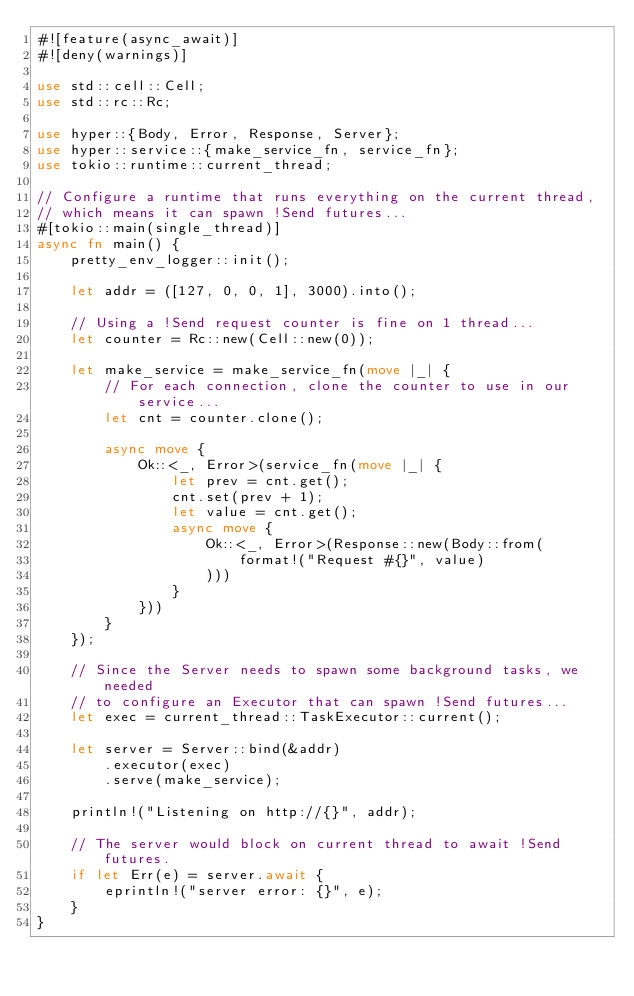Convert code to text. <code><loc_0><loc_0><loc_500><loc_500><_Rust_>#![feature(async_await)]
#![deny(warnings)]

use std::cell::Cell;
use std::rc::Rc;

use hyper::{Body, Error, Response, Server};
use hyper::service::{make_service_fn, service_fn};
use tokio::runtime::current_thread;

// Configure a runtime that runs everything on the current thread,
// which means it can spawn !Send futures...
#[tokio::main(single_thread)]
async fn main() {
    pretty_env_logger::init();

    let addr = ([127, 0, 0, 1], 3000).into();

    // Using a !Send request counter is fine on 1 thread...
    let counter = Rc::new(Cell::new(0));

    let make_service = make_service_fn(move |_| {
        // For each connection, clone the counter to use in our service...
        let cnt = counter.clone();

        async move {
            Ok::<_, Error>(service_fn(move |_| {
                let prev = cnt.get();
                cnt.set(prev + 1);
                let value = cnt.get();
                async move {
                    Ok::<_, Error>(Response::new(Body::from(
                        format!("Request #{}", value)
                    )))
                }
            }))
        }
    });

    // Since the Server needs to spawn some background tasks, we needed
    // to configure an Executor that can spawn !Send futures...
    let exec = current_thread::TaskExecutor::current();

    let server = Server::bind(&addr)
        .executor(exec)
        .serve(make_service);

    println!("Listening on http://{}", addr);

    // The server would block on current thread to await !Send futures.
    if let Err(e) = server.await {
        eprintln!("server error: {}", e);
    }
}

</code> 